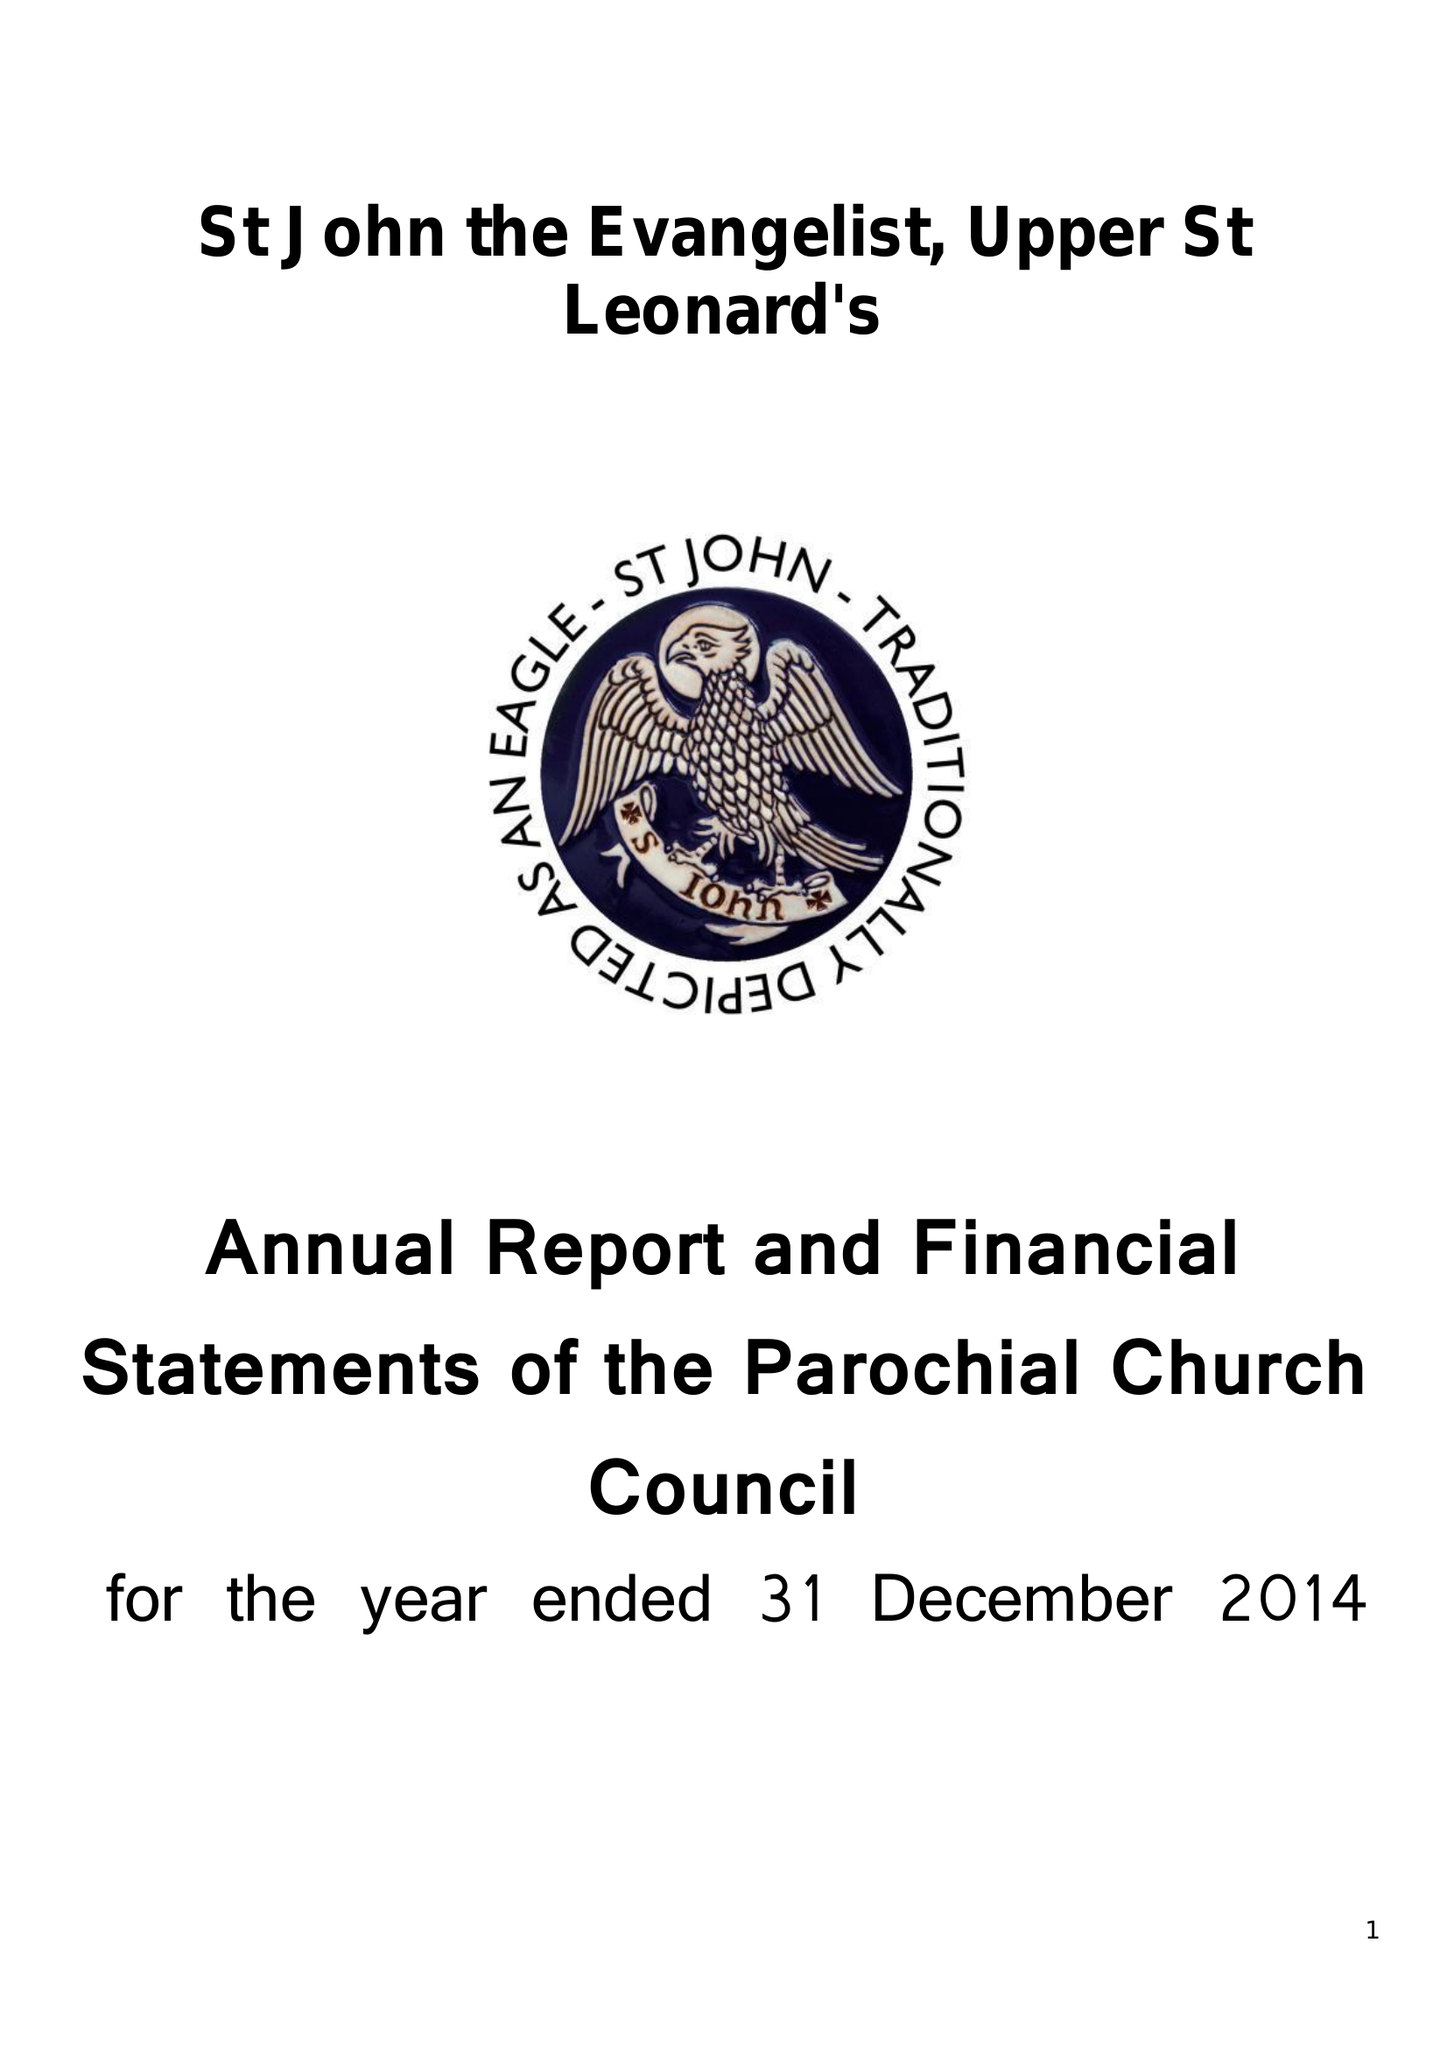What is the value for the address__postcode?
Answer the question using a single word or phrase. TN38 0LF 